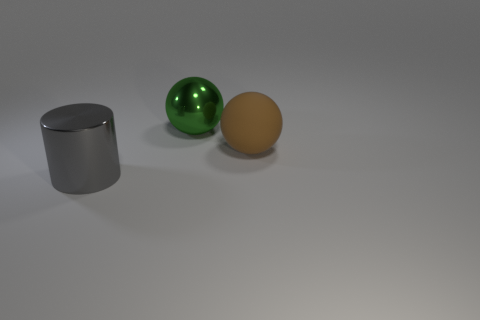Add 1 large gray shiny objects. How many objects exist? 4 Subtract all balls. How many objects are left? 1 Subtract all shiny cylinders. Subtract all big purple objects. How many objects are left? 2 Add 1 green things. How many green things are left? 2 Add 2 small blue cubes. How many small blue cubes exist? 2 Subtract 0 cyan cylinders. How many objects are left? 3 